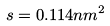Convert formula to latex. <formula><loc_0><loc_0><loc_500><loc_500>s = 0 . 1 1 4 n m ^ { 2 }</formula> 